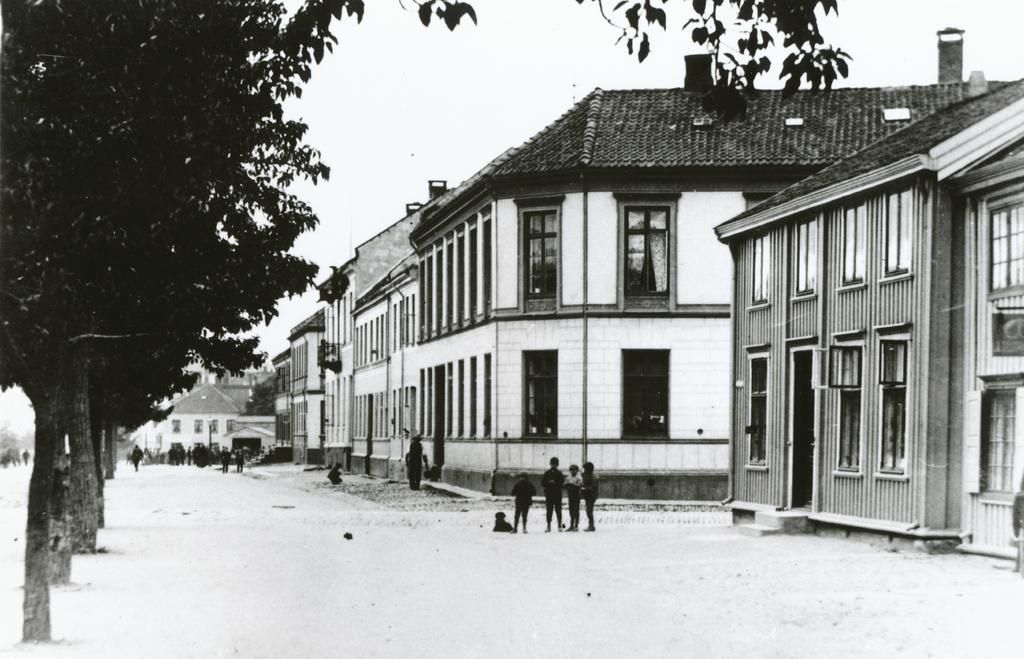What is the color scheme of the image? The image is black and white. How many people are present in the image? There are many people in the image. What type of structures can be seen in the image? There are buildings with windows in the image. What type of vegetation is present in the image? There are trees in the image. What is visible in the background of the image? The sky is visible in the background of the image. What type of letter is being delivered to the account in the image? There is no letter or account present in the image; it features a black and white scene with many people, buildings, trees, and a visible sky. 